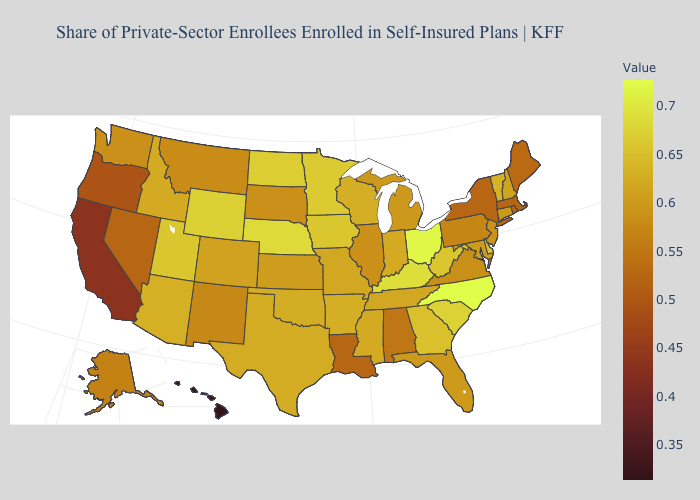Which states have the lowest value in the MidWest?
Quick response, please. Illinois, South Dakota. Among the states that border Maryland , which have the lowest value?
Short answer required. Pennsylvania. Among the states that border Arizona , does California have the lowest value?
Quick response, please. Yes. Which states hav the highest value in the South?
Quick response, please. North Carolina. Does Hawaii have the lowest value in the USA?
Answer briefly. Yes. 